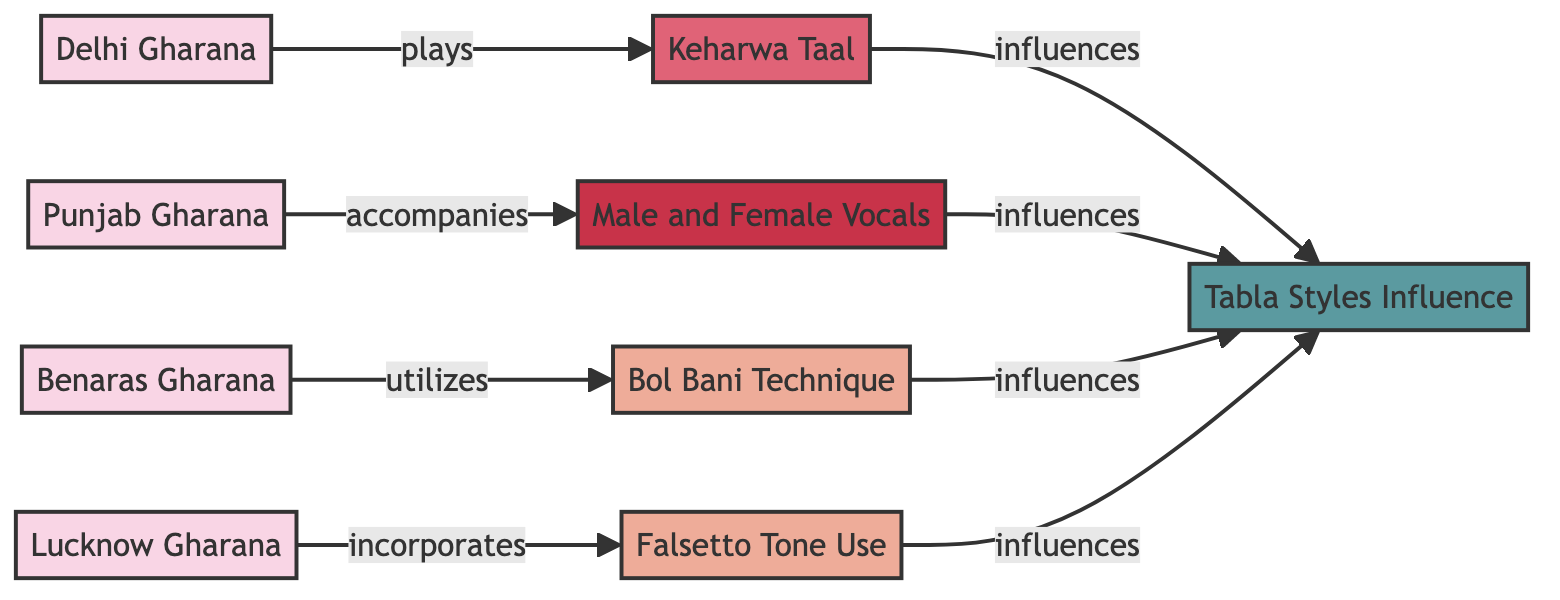What are the four Gharanas represented in the diagram? The diagram lists four Gharanas: Delhi Gharana, Punjab Gharana, Benaras Gharana, and Lucknow Gharana.
Answer: Delhi Gharana, Punjab Gharana, Benaras Gharana, Lucknow Gharana Which technique is utilized by the Benaras Gharana? The diagram shows that the Benaras Gharana utilizes the Bol Bani Technique, indicated by the arrow connecting these two nodes.
Answer: Bol Bani Technique How many nodes are categorized as techniques in the diagram? The diagram displays two techniques: Falsetto Tone Use and Bol Bani Technique, emphasizing the total count of these nodes.
Answer: 2 Which Gharana incorporates Falsetto Tone Use? The diagram has an arrow from the Lucknow Gharana to the Falsetto Tone Use node, indicating that Lucknow Gharana incorporates this technique.
Answer: Lucknow Gharana What influences the Tabla Styles according to the diagram? The diagram indicates that Keharwa Taal, Male and Female Vocals, Bol Bani Technique, and Falsetto Tone Use all influence Tabla Styles, requiring aggregation of their connections.
Answer: Keharwa Taal, Male and Female Vocals, Bol Bani Technique, Falsetto Tone Use How many edges are there in the diagram? The diagram has a total of eight edges connecting the nodes, which represent the relationships between different Gharanas, techniques, vocals, and Tabla styles.
Answer: 8 Which Gharana accompanies Male and Female Vocals? The diagram shows that the Punjab Gharana has an arrow pointing to the Male and Female Vocals node, indicating that it accompanies these vocals.
Answer: Punjab Gharana What is the relationship between Keharwa Taal and Tabla Styles? The diagram indicates that Keharwa Taal influences the Tabla Styles, as evidenced by the directed edge going from Keharwa Taal to Tabla Styles.
Answer: influences 